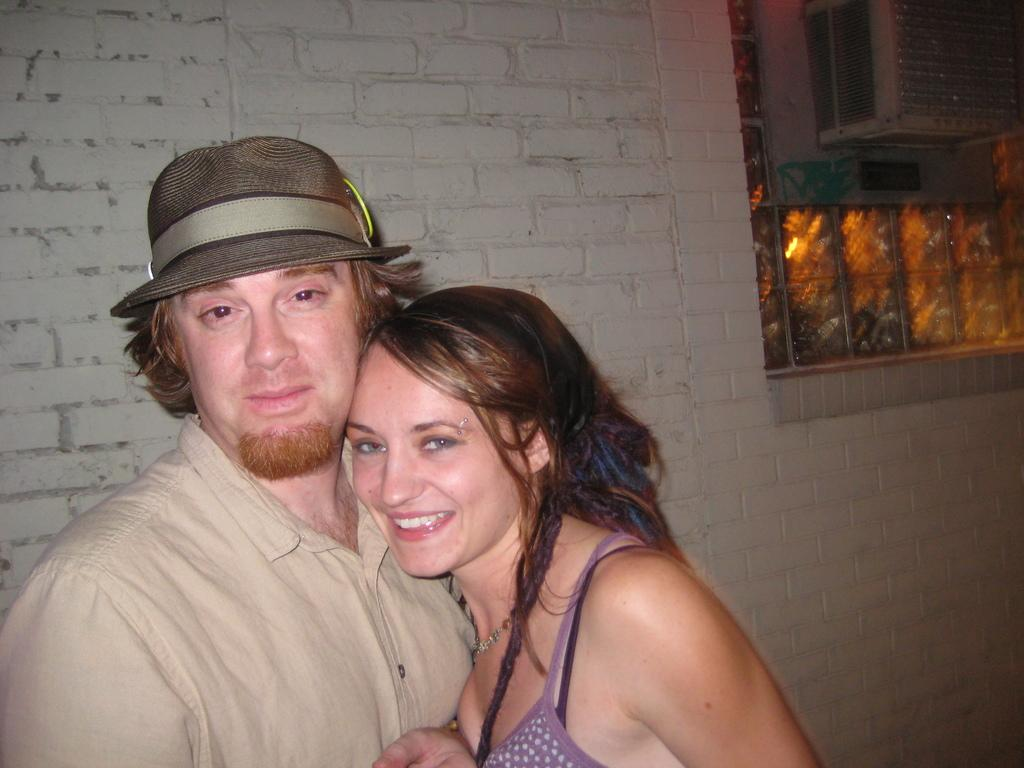What can be seen in the image that provides a view of the outside? There is a window in the image that provides a view of the outside. What are the two persons doing in the image? The two persons are standing near a big wall in the image. What is attached to the window in the image? There are objects attached to the window in the image. How does the window increase the temperature in the image? The window does not increase the temperature in the image; it is a passive object that allows light and air to pass through. Can you describe the kiss between the two persons in the image? There is no kiss between the two persons in the image; they are simply standing near a big wall. 